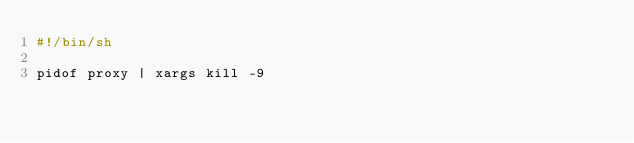<code> <loc_0><loc_0><loc_500><loc_500><_Bash_>#!/bin/sh

pidof proxy | xargs kill -9
</code> 